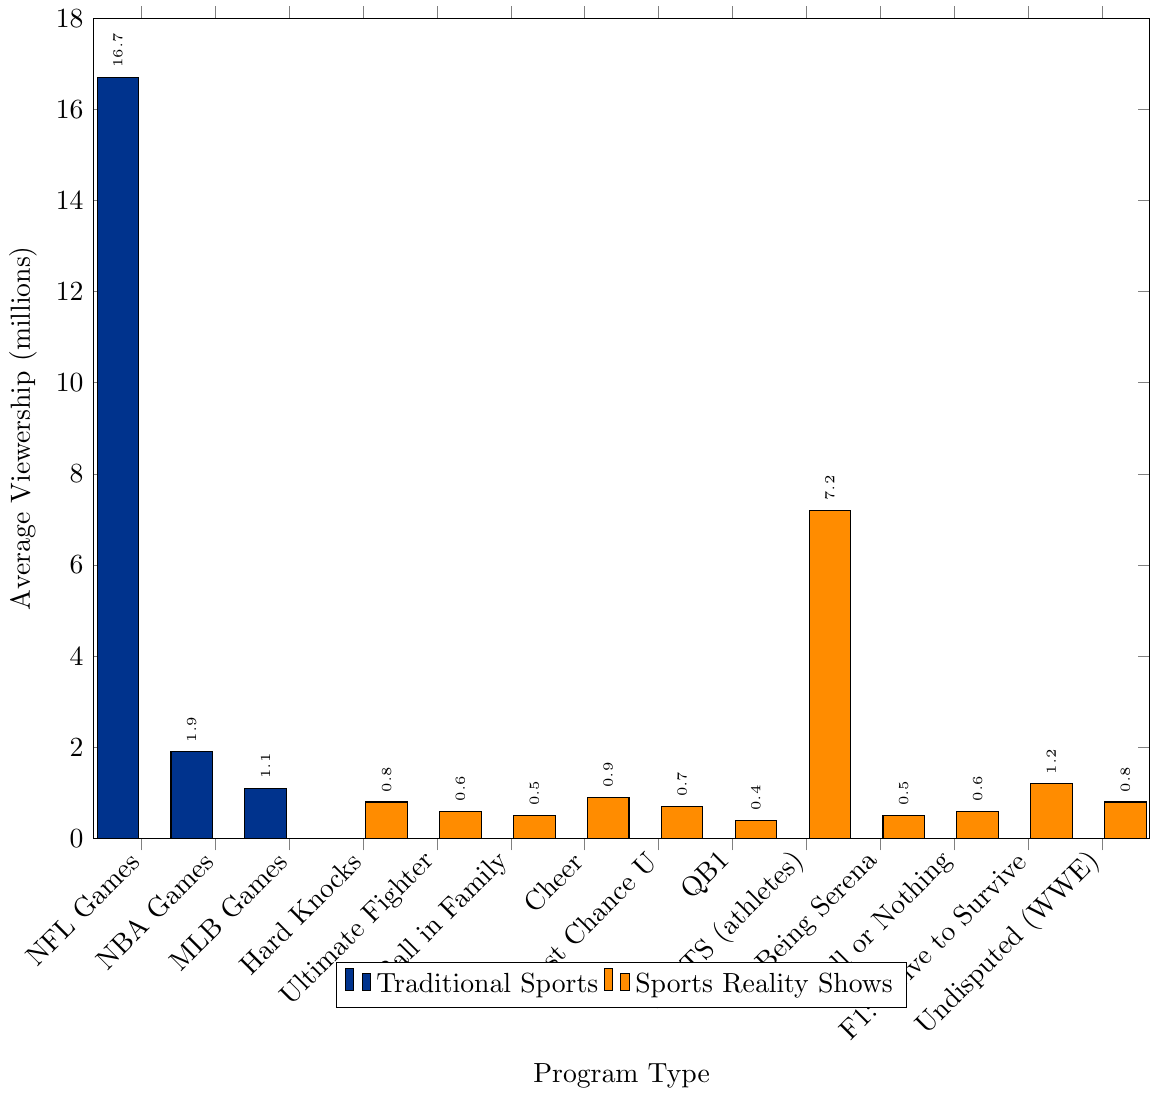Which program type has the highest viewership? The bar representing "NFL Games" is the tallest among all, indicating the highest average viewership.
Answer: NFL Games What is the viewership difference between NFL Games and NBA Games? The average viewership for NFL Games is 16.7 million, while for NBA Games, it is 1.9 million. The difference is calculated as 16.7 - 1.9.
Answer: 14.8 million Which sports-related reality show has the highest average viewership? The tallest bar among the sports-related reality shows is "Dancing with the Stars (athlete seasons)" with an average viewership of 7.2 million.
Answer: Dancing with the Stars (athlete seasons) How do the average viewerships of NFL Games and Cheer compare? NFL Games have an average viewership of 16.7 million, significantly higher than Cheer's 0.9 million.
Answer: NFL Games are higher What is the combined viewership of MLB Games, Being Serena, and F1: Drive to Survive? MLB Games have an average viewership of 1.1 million, Being Serena has 0.5 million, and F1: Drive to Survive has 1.2 million. Summing them gives 1.1 + 0.5 + 1.2.
Answer: 2.8 million What is the average viewership of the traditional sports programs mentioned? Adding the viewerships of NFL Games (16.7), NBA Games (1.9), and MLB Games (1.1) gives 16.7 + 1.9 + 1.1 = 19.7. Dividing by the number of programs (3), the average is 19.7 / 3.
Answer: 6.57 million Which program has a higher average viewership: All or Nothing or Last Chance U? The bar heights indicate that Last Chance U has an average viewership of 0.7 million, while All or Nothing has 0.6 million.
Answer: Last Chance U How many times higher is the viewership of NFL Games compared to QB1: Beyond the Lights? NFL Games have a viewership of 16.7 million, and QB1: Beyond the Lights has 0.4 million. Dividing the former by the latter, 16.7 / 0.4.
Answer: 41.75 times What is the total viewership for the top two sports-related reality shows? The two reality shows with the highest viewership are Dancing with the Stars (7.2 million) and F1: Drive to Survive (1.2 million). Their total viewership is 7.2 + 1.2.
Answer: 8.4 million Which program type has a lower viewership, Ball in the Family or Ultimate Fighter? The bar for Ball in the Family shows a viewership of 0.5 million, whereas Ultimate Fighter has 0.6 million. Ball in the Family has the lower viewership.
Answer: Ball in the Family 